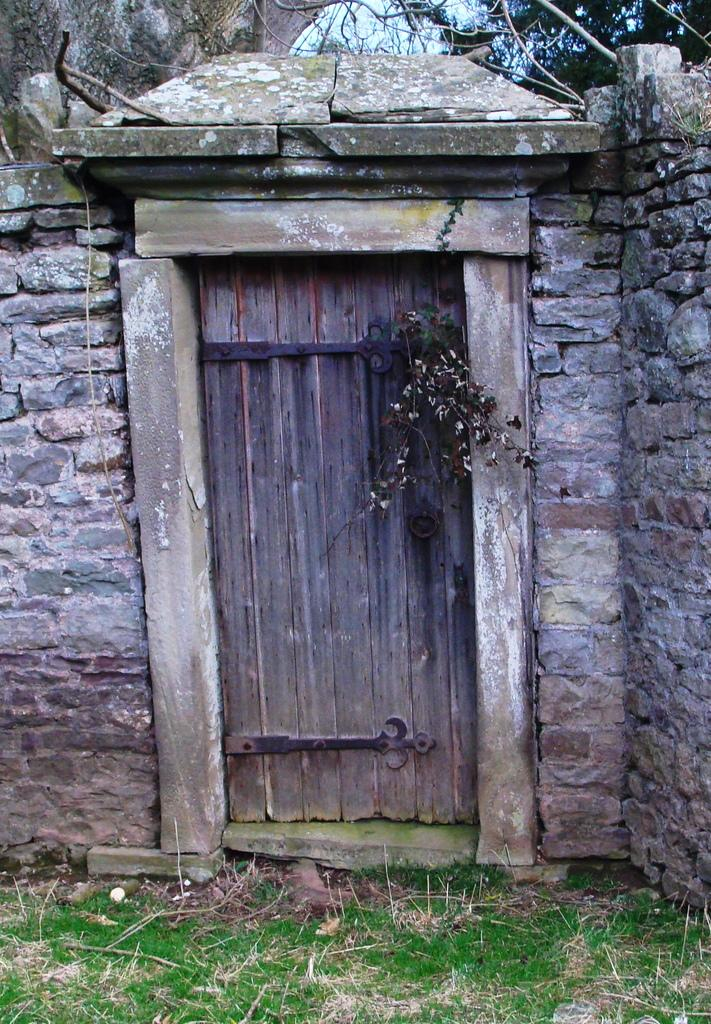What type of door is visible in the image? There is a wooden door in the image. What other natural elements can be seen in the image? There is a plant and a tree in the background of the image. What type of wall is present in the image? There is a stone wall in the image. What is the ground covered with in the image? There is grass visible on the ground in the image. How does the calculator help the society in the image? There is no calculator present in the image, so it cannot help society in this context. 